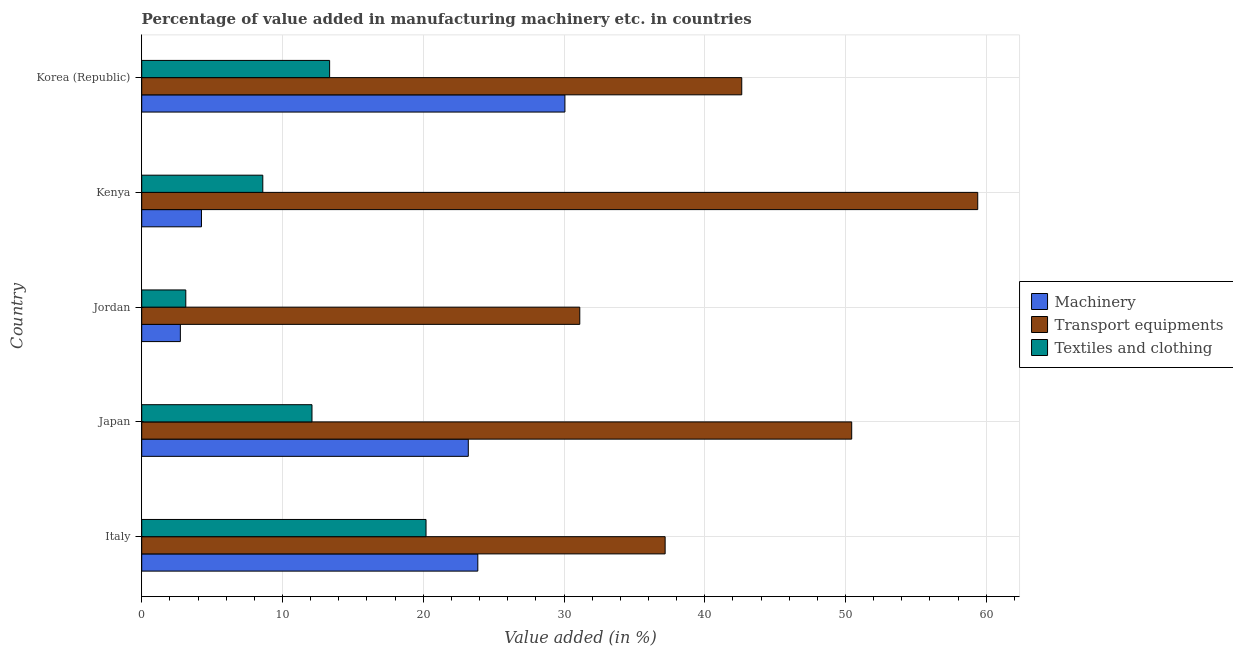How many groups of bars are there?
Offer a terse response. 5. Are the number of bars on each tick of the Y-axis equal?
Keep it short and to the point. Yes. What is the label of the 4th group of bars from the top?
Offer a very short reply. Japan. What is the value added in manufacturing transport equipments in Japan?
Provide a succinct answer. 50.44. Across all countries, what is the maximum value added in manufacturing textile and clothing?
Your answer should be very brief. 20.2. Across all countries, what is the minimum value added in manufacturing transport equipments?
Your answer should be compact. 31.12. In which country was the value added in manufacturing textile and clothing maximum?
Make the answer very short. Italy. In which country was the value added in manufacturing transport equipments minimum?
Ensure brevity in your answer.  Jordan. What is the total value added in manufacturing transport equipments in the graph?
Make the answer very short. 220.76. What is the difference between the value added in manufacturing textile and clothing in Japan and that in Jordan?
Ensure brevity in your answer.  8.96. What is the difference between the value added in manufacturing transport equipments in Kenya and the value added in manufacturing machinery in Japan?
Ensure brevity in your answer.  36.19. What is the average value added in manufacturing textile and clothing per country?
Your answer should be compact. 11.47. What is the difference between the value added in manufacturing machinery and value added in manufacturing transport equipments in Kenya?
Offer a very short reply. -55.15. In how many countries, is the value added in manufacturing machinery greater than 34 %?
Make the answer very short. 0. What is the ratio of the value added in manufacturing textile and clothing in Japan to that in Korea (Republic)?
Your answer should be very brief. 0.91. What is the difference between the highest and the second highest value added in manufacturing textile and clothing?
Give a very brief answer. 6.85. What is the difference between the highest and the lowest value added in manufacturing textile and clothing?
Give a very brief answer. 17.07. What does the 3rd bar from the top in Jordan represents?
Make the answer very short. Machinery. What does the 2nd bar from the bottom in Kenya represents?
Offer a very short reply. Transport equipments. Is it the case that in every country, the sum of the value added in manufacturing machinery and value added in manufacturing transport equipments is greater than the value added in manufacturing textile and clothing?
Ensure brevity in your answer.  Yes. Are all the bars in the graph horizontal?
Your answer should be very brief. Yes. How many countries are there in the graph?
Your answer should be very brief. 5. Are the values on the major ticks of X-axis written in scientific E-notation?
Make the answer very short. No. Does the graph contain grids?
Ensure brevity in your answer.  Yes. How are the legend labels stacked?
Offer a very short reply. Vertical. What is the title of the graph?
Give a very brief answer. Percentage of value added in manufacturing machinery etc. in countries. What is the label or title of the X-axis?
Your answer should be compact. Value added (in %). What is the label or title of the Y-axis?
Your answer should be compact. Country. What is the Value added (in %) of Machinery in Italy?
Provide a short and direct response. 23.88. What is the Value added (in %) of Transport equipments in Italy?
Offer a very short reply. 37.18. What is the Value added (in %) of Textiles and clothing in Italy?
Offer a terse response. 20.2. What is the Value added (in %) in Machinery in Japan?
Your response must be concise. 23.2. What is the Value added (in %) in Transport equipments in Japan?
Give a very brief answer. 50.44. What is the Value added (in %) in Textiles and clothing in Japan?
Your response must be concise. 12.1. What is the Value added (in %) in Machinery in Jordan?
Ensure brevity in your answer.  2.75. What is the Value added (in %) in Transport equipments in Jordan?
Keep it short and to the point. 31.12. What is the Value added (in %) of Textiles and clothing in Jordan?
Your response must be concise. 3.13. What is the Value added (in %) of Machinery in Kenya?
Give a very brief answer. 4.24. What is the Value added (in %) of Transport equipments in Kenya?
Give a very brief answer. 59.39. What is the Value added (in %) of Textiles and clothing in Kenya?
Keep it short and to the point. 8.6. What is the Value added (in %) in Machinery in Korea (Republic)?
Provide a short and direct response. 30.06. What is the Value added (in %) in Transport equipments in Korea (Republic)?
Provide a short and direct response. 42.63. What is the Value added (in %) of Textiles and clothing in Korea (Republic)?
Offer a very short reply. 13.35. Across all countries, what is the maximum Value added (in %) of Machinery?
Provide a short and direct response. 30.06. Across all countries, what is the maximum Value added (in %) of Transport equipments?
Ensure brevity in your answer.  59.39. Across all countries, what is the maximum Value added (in %) in Textiles and clothing?
Your response must be concise. 20.2. Across all countries, what is the minimum Value added (in %) in Machinery?
Give a very brief answer. 2.75. Across all countries, what is the minimum Value added (in %) of Transport equipments?
Provide a short and direct response. 31.12. Across all countries, what is the minimum Value added (in %) in Textiles and clothing?
Give a very brief answer. 3.13. What is the total Value added (in %) of Machinery in the graph?
Ensure brevity in your answer.  84.13. What is the total Value added (in %) of Transport equipments in the graph?
Give a very brief answer. 220.76. What is the total Value added (in %) in Textiles and clothing in the graph?
Your response must be concise. 57.37. What is the difference between the Value added (in %) of Machinery in Italy and that in Japan?
Make the answer very short. 0.68. What is the difference between the Value added (in %) of Transport equipments in Italy and that in Japan?
Provide a short and direct response. -13.25. What is the difference between the Value added (in %) in Textiles and clothing in Italy and that in Japan?
Keep it short and to the point. 8.1. What is the difference between the Value added (in %) in Machinery in Italy and that in Jordan?
Provide a succinct answer. 21.13. What is the difference between the Value added (in %) in Transport equipments in Italy and that in Jordan?
Offer a terse response. 6.06. What is the difference between the Value added (in %) of Textiles and clothing in Italy and that in Jordan?
Your response must be concise. 17.07. What is the difference between the Value added (in %) of Machinery in Italy and that in Kenya?
Your response must be concise. 19.63. What is the difference between the Value added (in %) of Transport equipments in Italy and that in Kenya?
Your answer should be compact. -22.21. What is the difference between the Value added (in %) of Textiles and clothing in Italy and that in Kenya?
Your answer should be very brief. 11.6. What is the difference between the Value added (in %) of Machinery in Italy and that in Korea (Republic)?
Your answer should be very brief. -6.19. What is the difference between the Value added (in %) in Transport equipments in Italy and that in Korea (Republic)?
Make the answer very short. -5.44. What is the difference between the Value added (in %) of Textiles and clothing in Italy and that in Korea (Republic)?
Your answer should be compact. 6.85. What is the difference between the Value added (in %) of Machinery in Japan and that in Jordan?
Make the answer very short. 20.46. What is the difference between the Value added (in %) of Transport equipments in Japan and that in Jordan?
Ensure brevity in your answer.  19.32. What is the difference between the Value added (in %) in Textiles and clothing in Japan and that in Jordan?
Ensure brevity in your answer.  8.96. What is the difference between the Value added (in %) of Machinery in Japan and that in Kenya?
Ensure brevity in your answer.  18.96. What is the difference between the Value added (in %) of Transport equipments in Japan and that in Kenya?
Ensure brevity in your answer.  -8.95. What is the difference between the Value added (in %) of Textiles and clothing in Japan and that in Kenya?
Ensure brevity in your answer.  3.49. What is the difference between the Value added (in %) of Machinery in Japan and that in Korea (Republic)?
Your response must be concise. -6.86. What is the difference between the Value added (in %) of Transport equipments in Japan and that in Korea (Republic)?
Provide a short and direct response. 7.81. What is the difference between the Value added (in %) of Textiles and clothing in Japan and that in Korea (Republic)?
Your response must be concise. -1.25. What is the difference between the Value added (in %) in Machinery in Jordan and that in Kenya?
Make the answer very short. -1.5. What is the difference between the Value added (in %) in Transport equipments in Jordan and that in Kenya?
Ensure brevity in your answer.  -28.27. What is the difference between the Value added (in %) of Textiles and clothing in Jordan and that in Kenya?
Your answer should be compact. -5.47. What is the difference between the Value added (in %) in Machinery in Jordan and that in Korea (Republic)?
Give a very brief answer. -27.32. What is the difference between the Value added (in %) of Transport equipments in Jordan and that in Korea (Republic)?
Provide a succinct answer. -11.51. What is the difference between the Value added (in %) of Textiles and clothing in Jordan and that in Korea (Republic)?
Your answer should be very brief. -10.22. What is the difference between the Value added (in %) in Machinery in Kenya and that in Korea (Republic)?
Give a very brief answer. -25.82. What is the difference between the Value added (in %) of Transport equipments in Kenya and that in Korea (Republic)?
Provide a short and direct response. 16.77. What is the difference between the Value added (in %) of Textiles and clothing in Kenya and that in Korea (Republic)?
Make the answer very short. -4.75. What is the difference between the Value added (in %) in Machinery in Italy and the Value added (in %) in Transport equipments in Japan?
Make the answer very short. -26.56. What is the difference between the Value added (in %) in Machinery in Italy and the Value added (in %) in Textiles and clothing in Japan?
Your answer should be compact. 11.78. What is the difference between the Value added (in %) of Transport equipments in Italy and the Value added (in %) of Textiles and clothing in Japan?
Give a very brief answer. 25.09. What is the difference between the Value added (in %) in Machinery in Italy and the Value added (in %) in Transport equipments in Jordan?
Your answer should be very brief. -7.24. What is the difference between the Value added (in %) of Machinery in Italy and the Value added (in %) of Textiles and clothing in Jordan?
Provide a short and direct response. 20.75. What is the difference between the Value added (in %) in Transport equipments in Italy and the Value added (in %) in Textiles and clothing in Jordan?
Offer a very short reply. 34.05. What is the difference between the Value added (in %) of Machinery in Italy and the Value added (in %) of Transport equipments in Kenya?
Your answer should be compact. -35.52. What is the difference between the Value added (in %) in Machinery in Italy and the Value added (in %) in Textiles and clothing in Kenya?
Provide a short and direct response. 15.28. What is the difference between the Value added (in %) of Transport equipments in Italy and the Value added (in %) of Textiles and clothing in Kenya?
Provide a succinct answer. 28.58. What is the difference between the Value added (in %) in Machinery in Italy and the Value added (in %) in Transport equipments in Korea (Republic)?
Provide a succinct answer. -18.75. What is the difference between the Value added (in %) of Machinery in Italy and the Value added (in %) of Textiles and clothing in Korea (Republic)?
Keep it short and to the point. 10.53. What is the difference between the Value added (in %) in Transport equipments in Italy and the Value added (in %) in Textiles and clothing in Korea (Republic)?
Give a very brief answer. 23.84. What is the difference between the Value added (in %) of Machinery in Japan and the Value added (in %) of Transport equipments in Jordan?
Keep it short and to the point. -7.92. What is the difference between the Value added (in %) of Machinery in Japan and the Value added (in %) of Textiles and clothing in Jordan?
Offer a terse response. 20.07. What is the difference between the Value added (in %) in Transport equipments in Japan and the Value added (in %) in Textiles and clothing in Jordan?
Keep it short and to the point. 47.31. What is the difference between the Value added (in %) in Machinery in Japan and the Value added (in %) in Transport equipments in Kenya?
Provide a short and direct response. -36.19. What is the difference between the Value added (in %) in Machinery in Japan and the Value added (in %) in Textiles and clothing in Kenya?
Make the answer very short. 14.6. What is the difference between the Value added (in %) in Transport equipments in Japan and the Value added (in %) in Textiles and clothing in Kenya?
Ensure brevity in your answer.  41.84. What is the difference between the Value added (in %) in Machinery in Japan and the Value added (in %) in Transport equipments in Korea (Republic)?
Offer a terse response. -19.43. What is the difference between the Value added (in %) of Machinery in Japan and the Value added (in %) of Textiles and clothing in Korea (Republic)?
Keep it short and to the point. 9.85. What is the difference between the Value added (in %) in Transport equipments in Japan and the Value added (in %) in Textiles and clothing in Korea (Republic)?
Make the answer very short. 37.09. What is the difference between the Value added (in %) of Machinery in Jordan and the Value added (in %) of Transport equipments in Kenya?
Give a very brief answer. -56.65. What is the difference between the Value added (in %) in Machinery in Jordan and the Value added (in %) in Textiles and clothing in Kenya?
Give a very brief answer. -5.86. What is the difference between the Value added (in %) in Transport equipments in Jordan and the Value added (in %) in Textiles and clothing in Kenya?
Make the answer very short. 22.52. What is the difference between the Value added (in %) of Machinery in Jordan and the Value added (in %) of Transport equipments in Korea (Republic)?
Your response must be concise. -39.88. What is the difference between the Value added (in %) in Machinery in Jordan and the Value added (in %) in Textiles and clothing in Korea (Republic)?
Provide a succinct answer. -10.6. What is the difference between the Value added (in %) of Transport equipments in Jordan and the Value added (in %) of Textiles and clothing in Korea (Republic)?
Your response must be concise. 17.77. What is the difference between the Value added (in %) in Machinery in Kenya and the Value added (in %) in Transport equipments in Korea (Republic)?
Offer a very short reply. -38.38. What is the difference between the Value added (in %) in Machinery in Kenya and the Value added (in %) in Textiles and clothing in Korea (Republic)?
Provide a short and direct response. -9.1. What is the difference between the Value added (in %) of Transport equipments in Kenya and the Value added (in %) of Textiles and clothing in Korea (Republic)?
Your answer should be very brief. 46.04. What is the average Value added (in %) of Machinery per country?
Offer a terse response. 16.83. What is the average Value added (in %) in Transport equipments per country?
Give a very brief answer. 44.15. What is the average Value added (in %) of Textiles and clothing per country?
Ensure brevity in your answer.  11.47. What is the difference between the Value added (in %) of Machinery and Value added (in %) of Transport equipments in Italy?
Make the answer very short. -13.31. What is the difference between the Value added (in %) of Machinery and Value added (in %) of Textiles and clothing in Italy?
Provide a succinct answer. 3.68. What is the difference between the Value added (in %) in Transport equipments and Value added (in %) in Textiles and clothing in Italy?
Offer a very short reply. 16.99. What is the difference between the Value added (in %) of Machinery and Value added (in %) of Transport equipments in Japan?
Offer a terse response. -27.24. What is the difference between the Value added (in %) in Machinery and Value added (in %) in Textiles and clothing in Japan?
Provide a short and direct response. 11.1. What is the difference between the Value added (in %) of Transport equipments and Value added (in %) of Textiles and clothing in Japan?
Offer a very short reply. 38.34. What is the difference between the Value added (in %) of Machinery and Value added (in %) of Transport equipments in Jordan?
Ensure brevity in your answer.  -28.38. What is the difference between the Value added (in %) in Machinery and Value added (in %) in Textiles and clothing in Jordan?
Your answer should be compact. -0.39. What is the difference between the Value added (in %) in Transport equipments and Value added (in %) in Textiles and clothing in Jordan?
Offer a very short reply. 27.99. What is the difference between the Value added (in %) in Machinery and Value added (in %) in Transport equipments in Kenya?
Ensure brevity in your answer.  -55.15. What is the difference between the Value added (in %) of Machinery and Value added (in %) of Textiles and clothing in Kenya?
Ensure brevity in your answer.  -4.36. What is the difference between the Value added (in %) in Transport equipments and Value added (in %) in Textiles and clothing in Kenya?
Your response must be concise. 50.79. What is the difference between the Value added (in %) in Machinery and Value added (in %) in Transport equipments in Korea (Republic)?
Your answer should be very brief. -12.56. What is the difference between the Value added (in %) in Machinery and Value added (in %) in Textiles and clothing in Korea (Republic)?
Offer a terse response. 16.72. What is the difference between the Value added (in %) of Transport equipments and Value added (in %) of Textiles and clothing in Korea (Republic)?
Your answer should be compact. 29.28. What is the ratio of the Value added (in %) in Machinery in Italy to that in Japan?
Keep it short and to the point. 1.03. What is the ratio of the Value added (in %) of Transport equipments in Italy to that in Japan?
Make the answer very short. 0.74. What is the ratio of the Value added (in %) in Textiles and clothing in Italy to that in Japan?
Offer a very short reply. 1.67. What is the ratio of the Value added (in %) in Machinery in Italy to that in Jordan?
Make the answer very short. 8.7. What is the ratio of the Value added (in %) in Transport equipments in Italy to that in Jordan?
Your answer should be very brief. 1.19. What is the ratio of the Value added (in %) of Textiles and clothing in Italy to that in Jordan?
Your answer should be compact. 6.45. What is the ratio of the Value added (in %) of Machinery in Italy to that in Kenya?
Your answer should be compact. 5.63. What is the ratio of the Value added (in %) of Transport equipments in Italy to that in Kenya?
Your answer should be compact. 0.63. What is the ratio of the Value added (in %) in Textiles and clothing in Italy to that in Kenya?
Provide a short and direct response. 2.35. What is the ratio of the Value added (in %) of Machinery in Italy to that in Korea (Republic)?
Your response must be concise. 0.79. What is the ratio of the Value added (in %) in Transport equipments in Italy to that in Korea (Republic)?
Offer a very short reply. 0.87. What is the ratio of the Value added (in %) in Textiles and clothing in Italy to that in Korea (Republic)?
Offer a terse response. 1.51. What is the ratio of the Value added (in %) in Machinery in Japan to that in Jordan?
Provide a succinct answer. 8.45. What is the ratio of the Value added (in %) of Transport equipments in Japan to that in Jordan?
Keep it short and to the point. 1.62. What is the ratio of the Value added (in %) in Textiles and clothing in Japan to that in Jordan?
Offer a very short reply. 3.86. What is the ratio of the Value added (in %) in Machinery in Japan to that in Kenya?
Offer a very short reply. 5.47. What is the ratio of the Value added (in %) in Transport equipments in Japan to that in Kenya?
Keep it short and to the point. 0.85. What is the ratio of the Value added (in %) of Textiles and clothing in Japan to that in Kenya?
Offer a very short reply. 1.41. What is the ratio of the Value added (in %) in Machinery in Japan to that in Korea (Republic)?
Keep it short and to the point. 0.77. What is the ratio of the Value added (in %) of Transport equipments in Japan to that in Korea (Republic)?
Offer a terse response. 1.18. What is the ratio of the Value added (in %) of Textiles and clothing in Japan to that in Korea (Republic)?
Your answer should be compact. 0.91. What is the ratio of the Value added (in %) in Machinery in Jordan to that in Kenya?
Make the answer very short. 0.65. What is the ratio of the Value added (in %) in Transport equipments in Jordan to that in Kenya?
Offer a very short reply. 0.52. What is the ratio of the Value added (in %) in Textiles and clothing in Jordan to that in Kenya?
Offer a very short reply. 0.36. What is the ratio of the Value added (in %) in Machinery in Jordan to that in Korea (Republic)?
Provide a short and direct response. 0.09. What is the ratio of the Value added (in %) of Transport equipments in Jordan to that in Korea (Republic)?
Provide a short and direct response. 0.73. What is the ratio of the Value added (in %) in Textiles and clothing in Jordan to that in Korea (Republic)?
Your answer should be compact. 0.23. What is the ratio of the Value added (in %) in Machinery in Kenya to that in Korea (Republic)?
Provide a succinct answer. 0.14. What is the ratio of the Value added (in %) in Transport equipments in Kenya to that in Korea (Republic)?
Provide a succinct answer. 1.39. What is the ratio of the Value added (in %) in Textiles and clothing in Kenya to that in Korea (Republic)?
Provide a short and direct response. 0.64. What is the difference between the highest and the second highest Value added (in %) in Machinery?
Give a very brief answer. 6.19. What is the difference between the highest and the second highest Value added (in %) of Transport equipments?
Ensure brevity in your answer.  8.95. What is the difference between the highest and the second highest Value added (in %) of Textiles and clothing?
Offer a very short reply. 6.85. What is the difference between the highest and the lowest Value added (in %) in Machinery?
Keep it short and to the point. 27.32. What is the difference between the highest and the lowest Value added (in %) of Transport equipments?
Keep it short and to the point. 28.27. What is the difference between the highest and the lowest Value added (in %) of Textiles and clothing?
Make the answer very short. 17.07. 